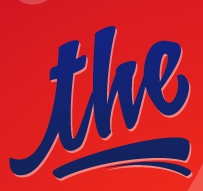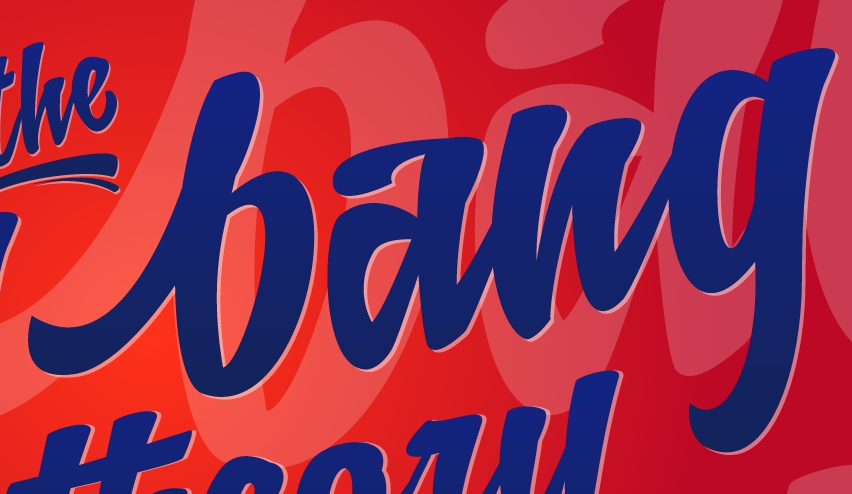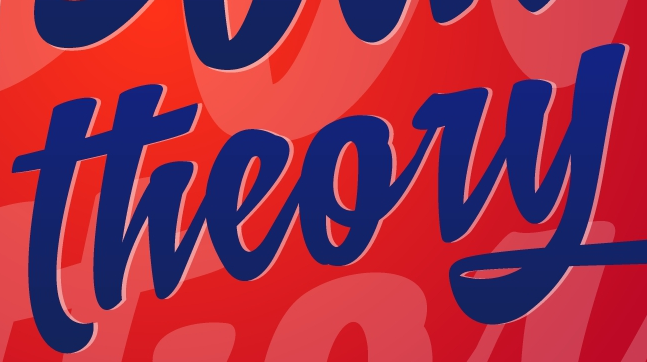Transcribe the words shown in these images in order, separated by a semicolon. the; bang; theory 